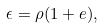<formula> <loc_0><loc_0><loc_500><loc_500>\epsilon = \rho ( 1 + e ) ,</formula> 